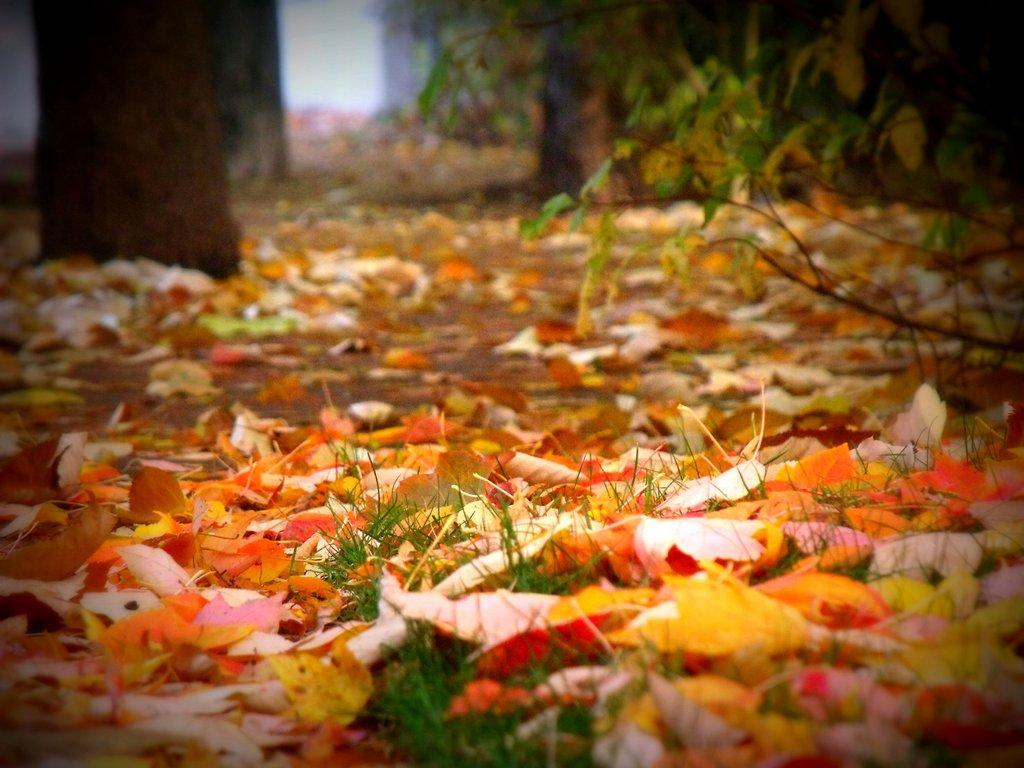What is the primary surface visible in the image? There is a ground in the image. What is covering the ground in the image? There are dry leaves on the ground. Where are the trees located in the image? The trees are on the left side of the image and located at the top of the image. How many pets can be seen balancing on the dry leaves in the image? There are no pets visible in the image, and the dry leaves are not being used for balancing. 